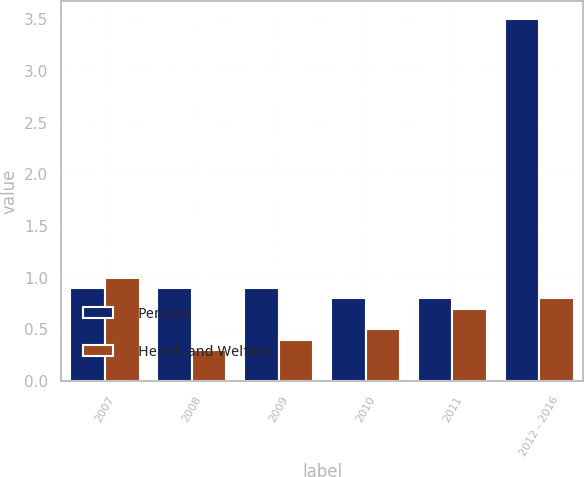<chart> <loc_0><loc_0><loc_500><loc_500><stacked_bar_chart><ecel><fcel>2007<fcel>2008<fcel>2009<fcel>2010<fcel>2011<fcel>2012 - 2016<nl><fcel>Pension<fcel>0.9<fcel>0.9<fcel>0.9<fcel>0.8<fcel>0.8<fcel>3.5<nl><fcel>Health and Welfare<fcel>1<fcel>0.3<fcel>0.4<fcel>0.5<fcel>0.7<fcel>0.8<nl></chart> 